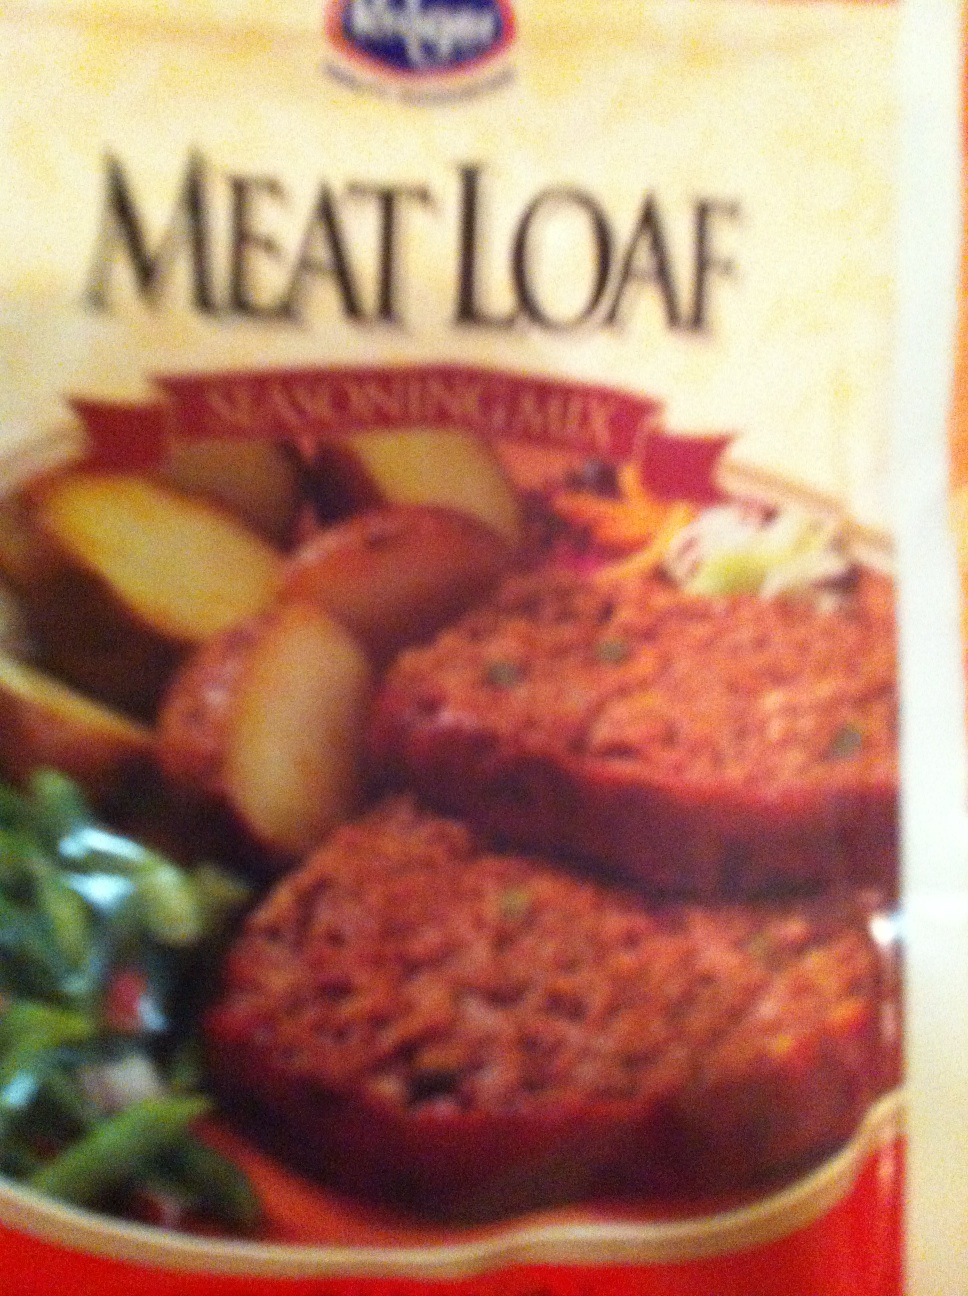What's the best way to cook this meatloaf? The meatloaf can be cooked in the oven. Generally, it's recommended to bake it at a moderate temperature, such as 350°F (175°C), until it's fully cooked through and has a nice crust on the top. Let it rest for a few minutes before serving to let the juices redistribute. 